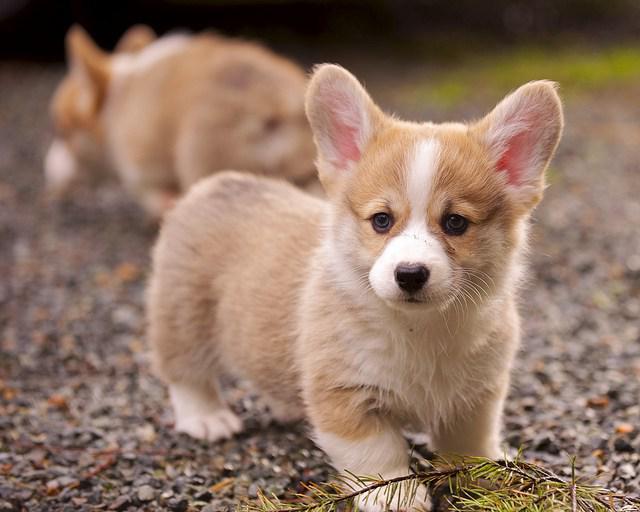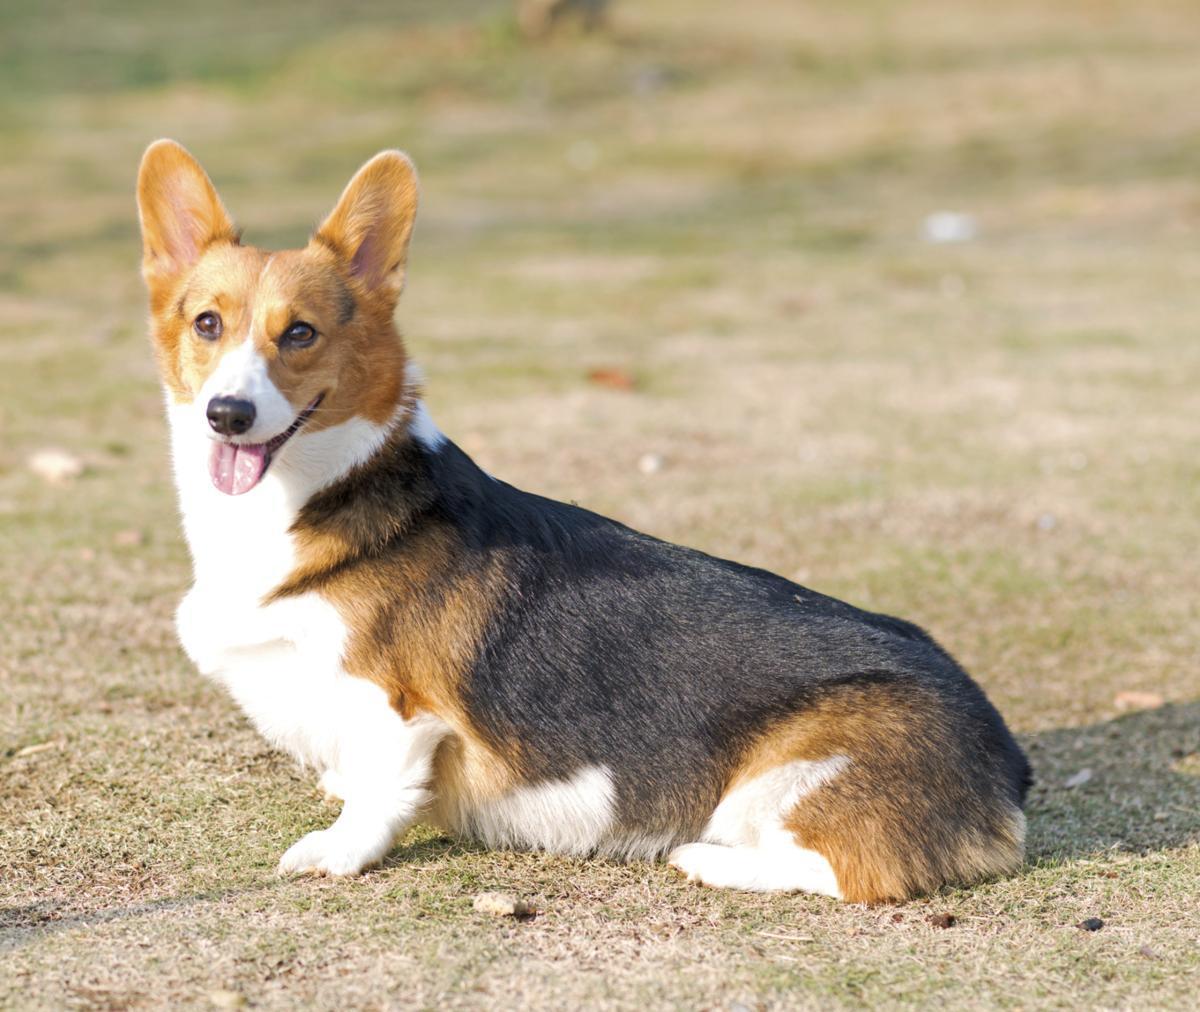The first image is the image on the left, the second image is the image on the right. Analyze the images presented: Is the assertion "There are two dogs in the left image." valid? Answer yes or no. Yes. The first image is the image on the left, the second image is the image on the right. Given the left and right images, does the statement "Only one of the dogs has its mouth open." hold true? Answer yes or no. Yes. 